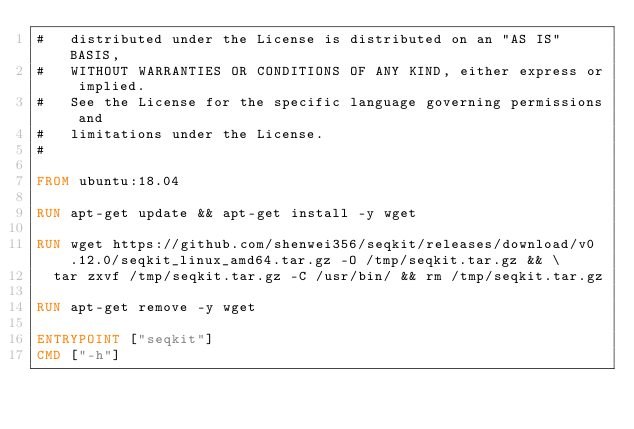<code> <loc_0><loc_0><loc_500><loc_500><_Dockerfile_>#   distributed under the License is distributed on an "AS IS" BASIS,
#   WITHOUT WARRANTIES OR CONDITIONS OF ANY KIND, either express or implied.
#   See the License for the specific language governing permissions and
#   limitations under the License.
#

FROM ubuntu:18.04

RUN apt-get update && apt-get install -y wget

RUN wget https://github.com/shenwei356/seqkit/releases/download/v0.12.0/seqkit_linux_amd64.tar.gz -O /tmp/seqkit.tar.gz && \
	tar zxvf /tmp/seqkit.tar.gz -C /usr/bin/ && rm /tmp/seqkit.tar.gz

RUN apt-get remove -y wget

ENTRYPOINT ["seqkit"]
CMD ["-h"]
</code> 